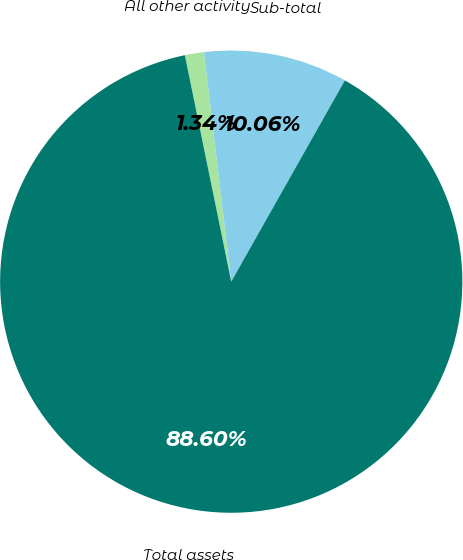Convert chart to OTSL. <chart><loc_0><loc_0><loc_500><loc_500><pie_chart><fcel>All other activity<fcel>Sub-total<fcel>Total assets<nl><fcel>1.34%<fcel>10.06%<fcel>88.6%<nl></chart> 